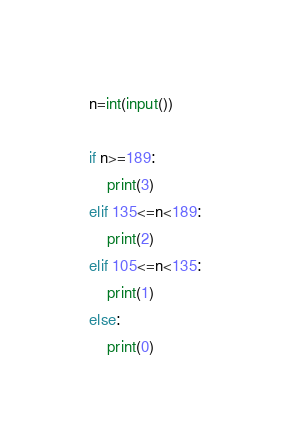Convert code to text. <code><loc_0><loc_0><loc_500><loc_500><_Python_>n=int(input())

if n>=189:
    print(3)
elif 135<=n<189:
    print(2)
elif 105<=n<135:
    print(1)
else:
    print(0)</code> 